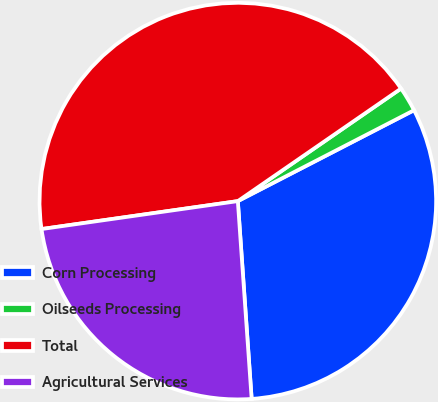<chart> <loc_0><loc_0><loc_500><loc_500><pie_chart><fcel>Corn Processing<fcel>Oilseeds Processing<fcel>Total<fcel>Agricultural Services<nl><fcel>31.47%<fcel>2.03%<fcel>42.64%<fcel>23.86%<nl></chart> 